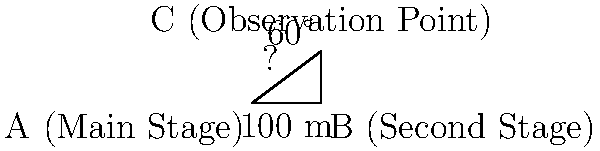At a Hong Kong-themed cultural festival in Shanghai, you're planning the layout of two stages. The main stage (A) and the second stage (B) are connected by a straight path that's 100 meters long. From an observation point (C), you can see both stages. The angle between the line of sight to the main stage and the path connecting the stages is 60°. If the observation point forms a right angle with the two stages, what is the distance between the observation point and the main stage? Let's approach this step-by-step using trigonometry:

1) We have a right-angled triangle ABC, where:
   - AB is the distance between the stages (100 m)
   - ∠BCA = 90° (given)
   - ∠CAB = 60° (given)

2) We need to find AC, which is the distance from the observation point to the main stage.

3) In a right-angled triangle, we can use the tangent ratio:

   $\tan \theta = \frac{\text{opposite}}{\text{adjacent}}$

4) In this case:
   $\tan 60° = \frac{AB}{BC}$

5) We know that $\tan 60° = \sqrt{3}$, so:

   $\sqrt{3} = \frac{100}{BC}$

6) Solving for BC:
   $BC = \frac{100}{\sqrt{3}} \approx 57.74$ meters

7) Now we have a right-angled triangle where we know the hypotenuse (AC) and one side (BC).

8) We can use the Pythagorean theorem to find AC:

   $AC^2 = AB^2 + BC^2$

9) Substituting the values:

   $AC^2 = 100^2 + (\frac{100}{\sqrt{3}})^2$

10) Simplifying:
    $AC^2 = 10000 + \frac{10000}{3} = \frac{40000}{3}$

11) Taking the square root:
    $AC = \sqrt{\frac{40000}{3}} \approx 115.47$ meters

Therefore, the distance between the observation point and the main stage is approximately 115.47 meters.
Answer: $\sqrt{\frac{40000}{3}}$ meters (≈ 115.47 m) 